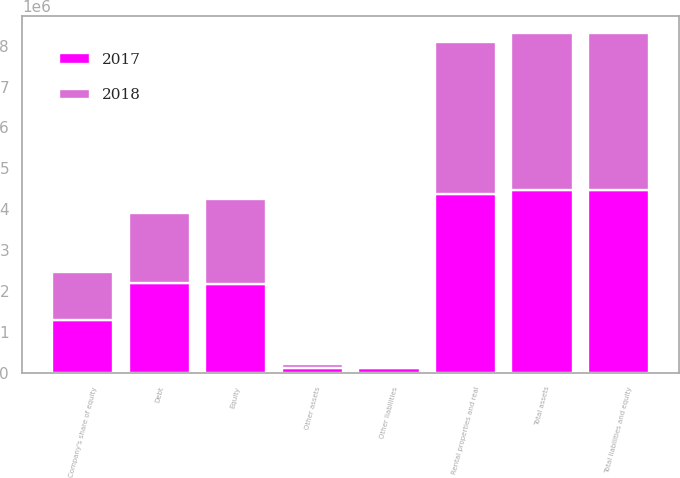<chart> <loc_0><loc_0><loc_500><loc_500><stacked_bar_chart><ecel><fcel>Rental properties and real<fcel>Other assets<fcel>Total assets<fcel>Debt<fcel>Other liabilities<fcel>Equity<fcel>Total liabilities and equity<fcel>Company's share of equity<nl><fcel>2017<fcel>4.36799e+06<fcel>104119<fcel>4.47211e+06<fcel>2.19076e+06<fcel>106316<fcel>2.17503e+06<fcel>4.47211e+06<fcel>1.30014e+06<nl><fcel>2018<fcel>3.72278e+06<fcel>110333<fcel>3.83311e+06<fcel>1.70505e+06<fcel>45515<fcel>2.08254e+06<fcel>3.83311e+06<fcel>1.15598e+06<nl></chart> 